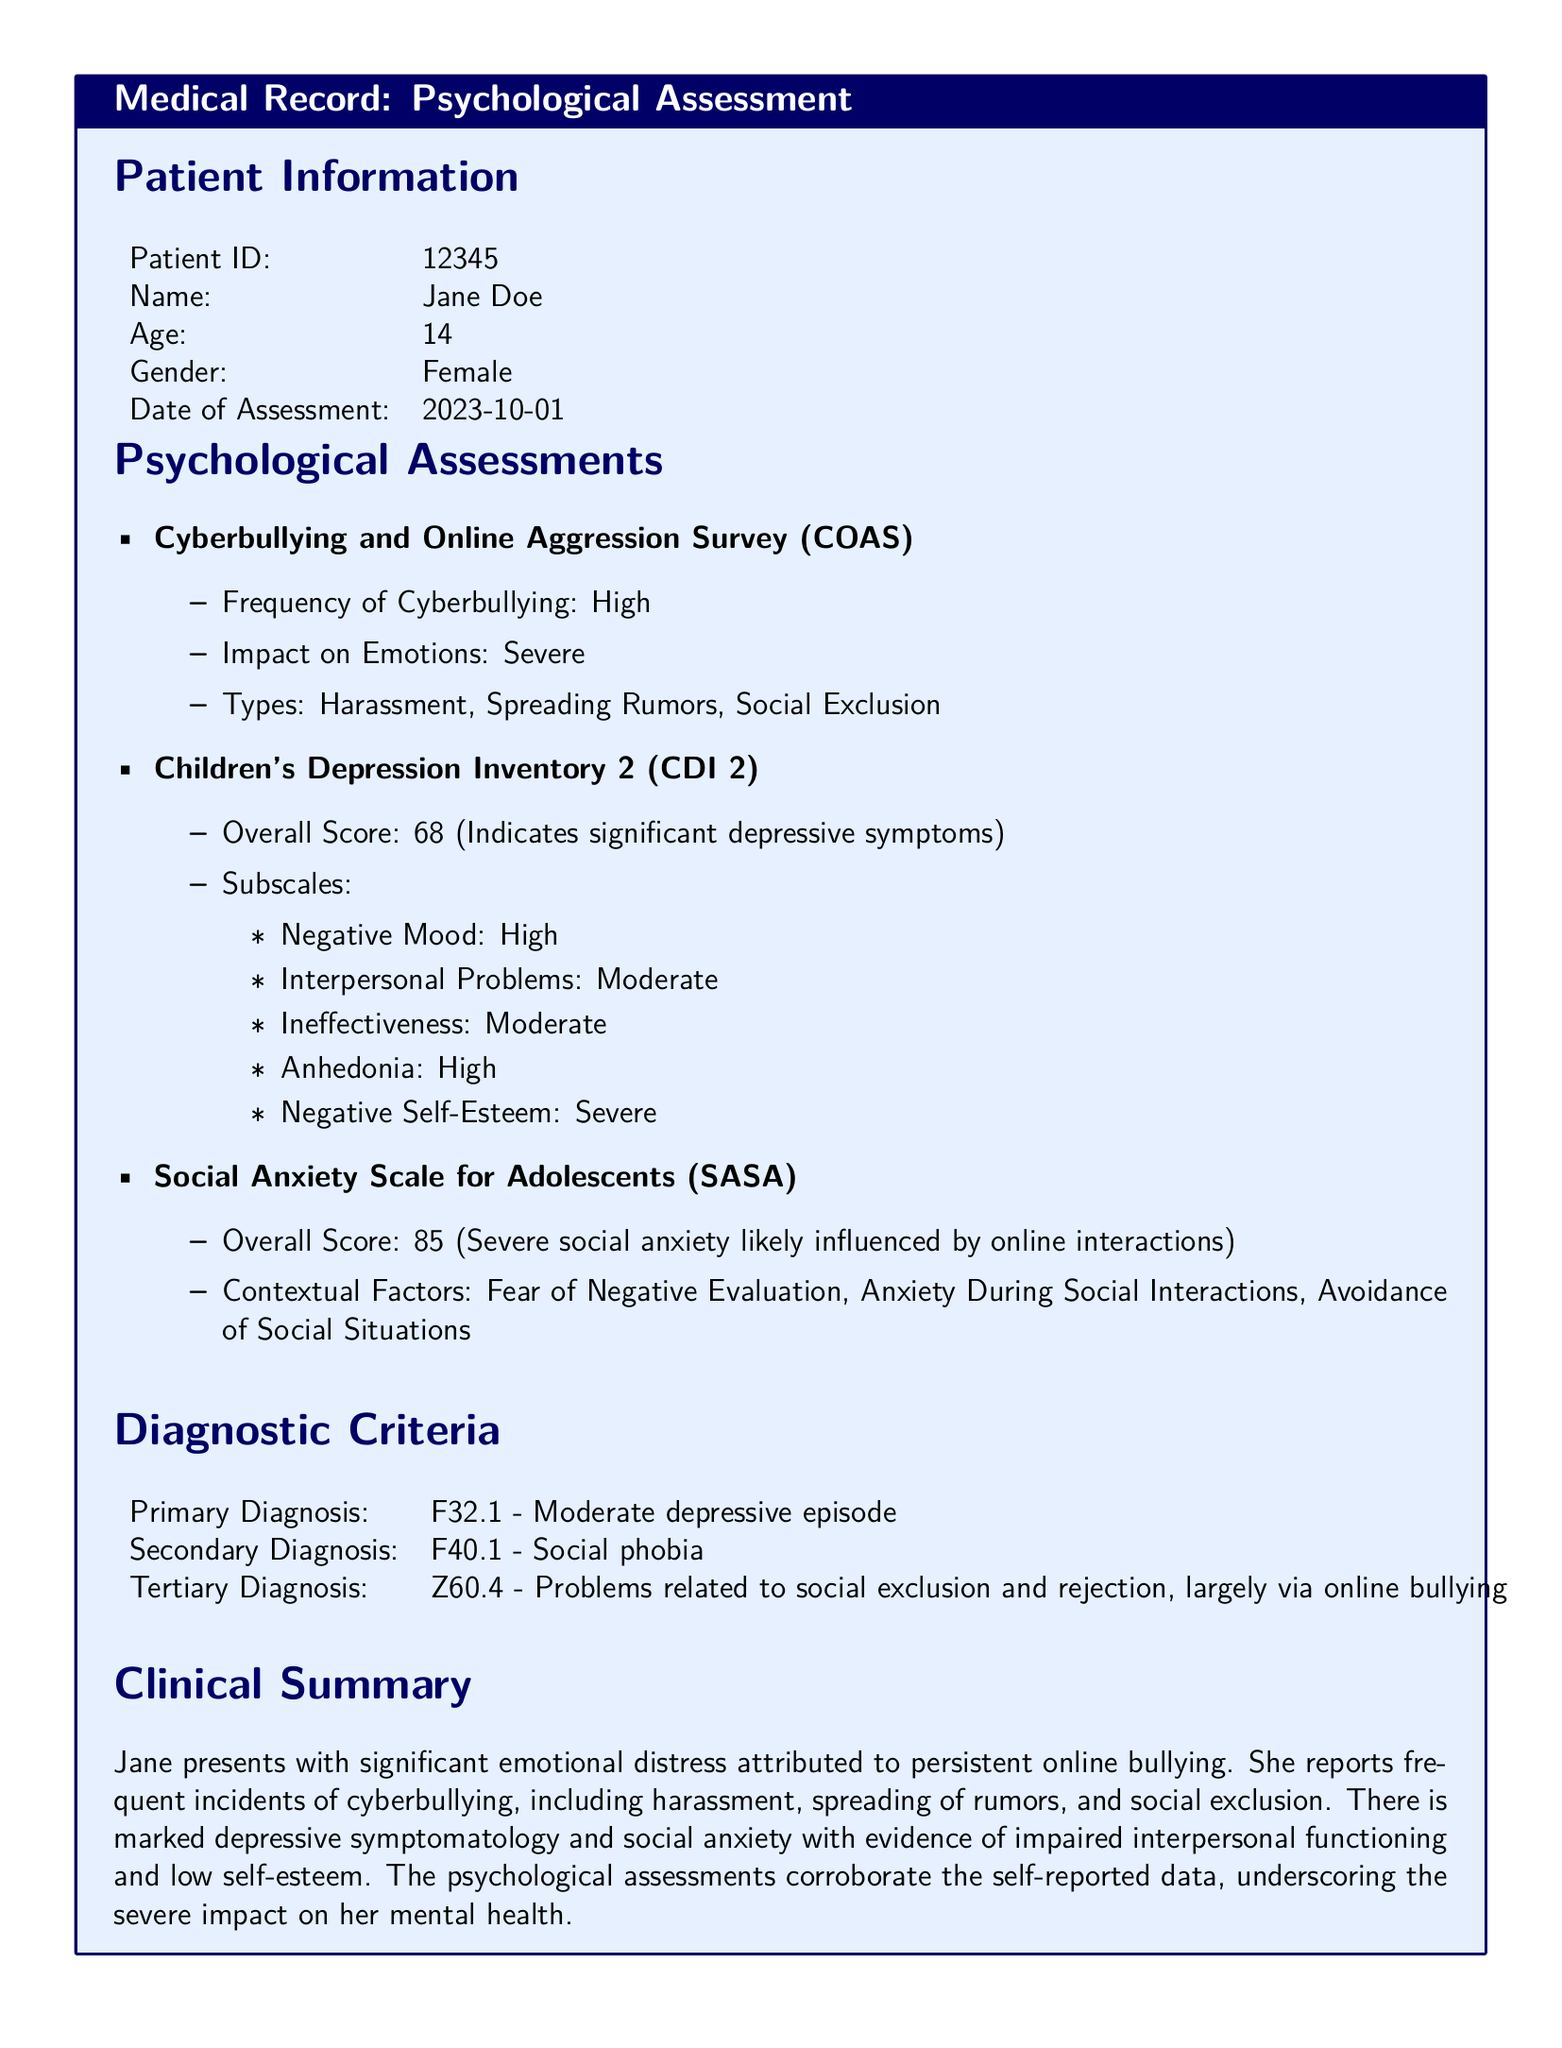What is the patient's age? The patient's age is listed in the Patient Information section of the document.
Answer: 14 What is the primary diagnosis? The primary diagnosis is specified in the Diagnostic Criteria section.
Answer: F32.1 - Moderate depressive episode What was the overall score for the Children's Depression Inventory 2? The overall score is provided in the Psychological Assessments section under CDI 2.
Answer: 68 What type of bullying did Jane experience most frequently? The types of bullying are indicated in the Psychological Assessments section under COAS.
Answer: Harassment, Spreading Rumors, Social Exclusion What is the overall score on the Social Anxiety Scale for Adolescents? The overall score is mentioned in the Psychological Assessments section under SASA.
Answer: 85 What subscale of the Children's Depression Inventory shows severe issues? The subscales of the CDI 2 are listed in a bulleted format, detailing levels of concern.
Answer: Negative Self-Esteem What emotional impact did the online bullying have on Jane? The emotional impact is summarized in the Clinical Summary section, indicating severity.
Answer: Severe What significant emotional distress is attributed to? The Clinical Summary section links the emotional distress to specific causes mentioned.
Answer: Persistent online bullying What is a contextual factor influencing Jane's social anxiety? Contextual factors are identified in the Psychological Assessments section under SASA.
Answer: Fear of Negative Evaluation 